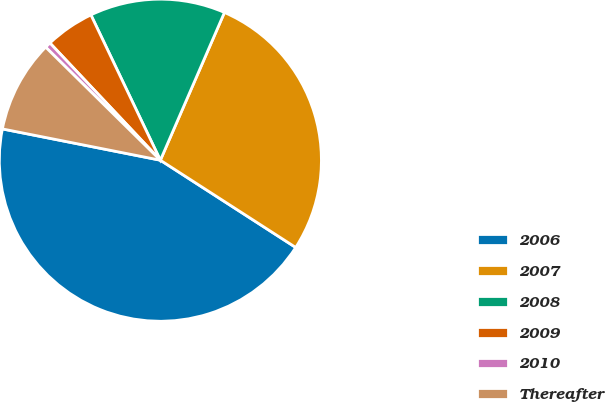Convert chart to OTSL. <chart><loc_0><loc_0><loc_500><loc_500><pie_chart><fcel>2006<fcel>2007<fcel>2008<fcel>2009<fcel>2010<fcel>Thereafter<nl><fcel>44.0%<fcel>27.6%<fcel>13.61%<fcel>4.93%<fcel>0.59%<fcel>9.27%<nl></chart> 